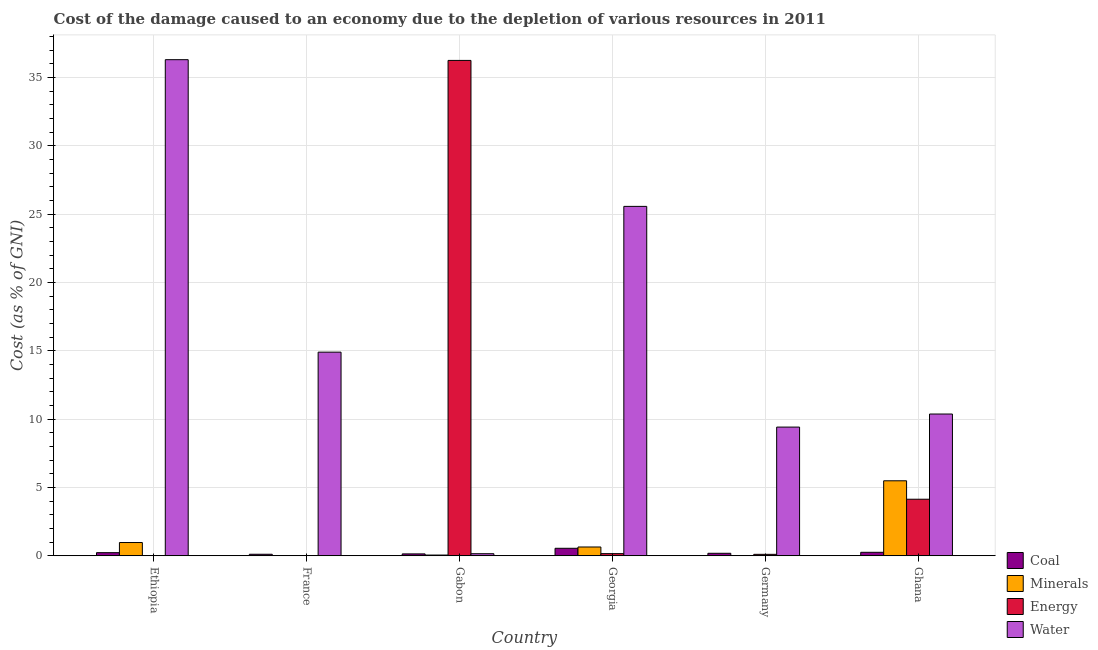How many different coloured bars are there?
Provide a succinct answer. 4. How many groups of bars are there?
Offer a terse response. 6. Are the number of bars on each tick of the X-axis equal?
Keep it short and to the point. Yes. How many bars are there on the 6th tick from the right?
Give a very brief answer. 4. What is the label of the 2nd group of bars from the left?
Make the answer very short. France. In how many cases, is the number of bars for a given country not equal to the number of legend labels?
Ensure brevity in your answer.  0. What is the cost of damage due to depletion of minerals in France?
Your answer should be compact. 0. Across all countries, what is the maximum cost of damage due to depletion of energy?
Provide a short and direct response. 36.26. Across all countries, what is the minimum cost of damage due to depletion of energy?
Your answer should be compact. 0. In which country was the cost of damage due to depletion of coal minimum?
Offer a very short reply. France. What is the total cost of damage due to depletion of coal in the graph?
Keep it short and to the point. 1.47. What is the difference between the cost of damage due to depletion of water in Ethiopia and that in France?
Your answer should be very brief. 21.41. What is the difference between the cost of damage due to depletion of water in Ethiopia and the cost of damage due to depletion of coal in France?
Your answer should be compact. 36.2. What is the average cost of damage due to depletion of energy per country?
Make the answer very short. 6.78. What is the difference between the cost of damage due to depletion of coal and cost of damage due to depletion of energy in Georgia?
Keep it short and to the point. 0.39. In how many countries, is the cost of damage due to depletion of coal greater than 35 %?
Your response must be concise. 0. What is the ratio of the cost of damage due to depletion of minerals in Gabon to that in Germany?
Your answer should be very brief. 79.27. Is the cost of damage due to depletion of water in Ethiopia less than that in Ghana?
Offer a very short reply. No. Is the difference between the cost of damage due to depletion of minerals in Ethiopia and Gabon greater than the difference between the cost of damage due to depletion of coal in Ethiopia and Gabon?
Your answer should be compact. Yes. What is the difference between the highest and the second highest cost of damage due to depletion of energy?
Ensure brevity in your answer.  32.12. What is the difference between the highest and the lowest cost of damage due to depletion of energy?
Keep it short and to the point. 36.25. In how many countries, is the cost of damage due to depletion of minerals greater than the average cost of damage due to depletion of minerals taken over all countries?
Make the answer very short. 1. What does the 1st bar from the left in Georgia represents?
Keep it short and to the point. Coal. What does the 2nd bar from the right in Germany represents?
Offer a terse response. Energy. Is it the case that in every country, the sum of the cost of damage due to depletion of coal and cost of damage due to depletion of minerals is greater than the cost of damage due to depletion of energy?
Ensure brevity in your answer.  No. Are all the bars in the graph horizontal?
Your response must be concise. No. How many countries are there in the graph?
Offer a terse response. 6. What is the difference between two consecutive major ticks on the Y-axis?
Offer a very short reply. 5. Are the values on the major ticks of Y-axis written in scientific E-notation?
Keep it short and to the point. No. What is the title of the graph?
Provide a short and direct response. Cost of the damage caused to an economy due to the depletion of various resources in 2011 . What is the label or title of the Y-axis?
Your response must be concise. Cost (as % of GNI). What is the Cost (as % of GNI) of Coal in Ethiopia?
Give a very brief answer. 0.23. What is the Cost (as % of GNI) in Minerals in Ethiopia?
Provide a short and direct response. 0.97. What is the Cost (as % of GNI) of Energy in Ethiopia?
Ensure brevity in your answer.  0. What is the Cost (as % of GNI) of Water in Ethiopia?
Provide a succinct answer. 36.31. What is the Cost (as % of GNI) of Coal in France?
Your response must be concise. 0.11. What is the Cost (as % of GNI) of Minerals in France?
Ensure brevity in your answer.  0. What is the Cost (as % of GNI) in Energy in France?
Make the answer very short. 0.02. What is the Cost (as % of GNI) of Water in France?
Make the answer very short. 14.91. What is the Cost (as % of GNI) of Coal in Gabon?
Offer a terse response. 0.14. What is the Cost (as % of GNI) in Minerals in Gabon?
Offer a terse response. 0.05. What is the Cost (as % of GNI) in Energy in Gabon?
Offer a very short reply. 36.26. What is the Cost (as % of GNI) of Water in Gabon?
Your answer should be compact. 0.15. What is the Cost (as % of GNI) of Coal in Georgia?
Ensure brevity in your answer.  0.55. What is the Cost (as % of GNI) in Minerals in Georgia?
Give a very brief answer. 0.64. What is the Cost (as % of GNI) of Energy in Georgia?
Your answer should be very brief. 0.16. What is the Cost (as % of GNI) in Water in Georgia?
Give a very brief answer. 25.57. What is the Cost (as % of GNI) of Coal in Germany?
Provide a short and direct response. 0.18. What is the Cost (as % of GNI) in Minerals in Germany?
Provide a short and direct response. 0. What is the Cost (as % of GNI) in Energy in Germany?
Offer a very short reply. 0.11. What is the Cost (as % of GNI) in Water in Germany?
Make the answer very short. 9.42. What is the Cost (as % of GNI) of Coal in Ghana?
Offer a terse response. 0.25. What is the Cost (as % of GNI) in Minerals in Ghana?
Keep it short and to the point. 5.49. What is the Cost (as % of GNI) in Energy in Ghana?
Ensure brevity in your answer.  4.14. What is the Cost (as % of GNI) of Water in Ghana?
Make the answer very short. 10.38. Across all countries, what is the maximum Cost (as % of GNI) in Coal?
Ensure brevity in your answer.  0.55. Across all countries, what is the maximum Cost (as % of GNI) of Minerals?
Make the answer very short. 5.49. Across all countries, what is the maximum Cost (as % of GNI) of Energy?
Provide a succinct answer. 36.26. Across all countries, what is the maximum Cost (as % of GNI) in Water?
Keep it short and to the point. 36.31. Across all countries, what is the minimum Cost (as % of GNI) in Coal?
Provide a succinct answer. 0.11. Across all countries, what is the minimum Cost (as % of GNI) of Minerals?
Ensure brevity in your answer.  0. Across all countries, what is the minimum Cost (as % of GNI) of Energy?
Your answer should be compact. 0. Across all countries, what is the minimum Cost (as % of GNI) in Water?
Offer a terse response. 0.15. What is the total Cost (as % of GNI) of Coal in the graph?
Provide a succinct answer. 1.47. What is the total Cost (as % of GNI) in Minerals in the graph?
Your response must be concise. 7.16. What is the total Cost (as % of GNI) of Energy in the graph?
Offer a terse response. 40.68. What is the total Cost (as % of GNI) of Water in the graph?
Make the answer very short. 96.74. What is the difference between the Cost (as % of GNI) of Coal in Ethiopia and that in France?
Offer a very short reply. 0.12. What is the difference between the Cost (as % of GNI) of Minerals in Ethiopia and that in France?
Your answer should be very brief. 0.97. What is the difference between the Cost (as % of GNI) in Energy in Ethiopia and that in France?
Your answer should be compact. -0.01. What is the difference between the Cost (as % of GNI) in Water in Ethiopia and that in France?
Your answer should be compact. 21.41. What is the difference between the Cost (as % of GNI) in Coal in Ethiopia and that in Gabon?
Make the answer very short. 0.09. What is the difference between the Cost (as % of GNI) of Minerals in Ethiopia and that in Gabon?
Offer a very short reply. 0.92. What is the difference between the Cost (as % of GNI) of Energy in Ethiopia and that in Gabon?
Offer a terse response. -36.25. What is the difference between the Cost (as % of GNI) in Water in Ethiopia and that in Gabon?
Your answer should be compact. 36.16. What is the difference between the Cost (as % of GNI) in Coal in Ethiopia and that in Georgia?
Your answer should be compact. -0.32. What is the difference between the Cost (as % of GNI) in Minerals in Ethiopia and that in Georgia?
Provide a short and direct response. 0.33. What is the difference between the Cost (as % of GNI) of Energy in Ethiopia and that in Georgia?
Keep it short and to the point. -0.16. What is the difference between the Cost (as % of GNI) in Water in Ethiopia and that in Georgia?
Your response must be concise. 10.74. What is the difference between the Cost (as % of GNI) in Coal in Ethiopia and that in Germany?
Your response must be concise. 0.05. What is the difference between the Cost (as % of GNI) in Energy in Ethiopia and that in Germany?
Give a very brief answer. -0.1. What is the difference between the Cost (as % of GNI) of Water in Ethiopia and that in Germany?
Keep it short and to the point. 26.89. What is the difference between the Cost (as % of GNI) in Coal in Ethiopia and that in Ghana?
Your answer should be very brief. -0.03. What is the difference between the Cost (as % of GNI) in Minerals in Ethiopia and that in Ghana?
Provide a succinct answer. -4.52. What is the difference between the Cost (as % of GNI) in Energy in Ethiopia and that in Ghana?
Make the answer very short. -4.14. What is the difference between the Cost (as % of GNI) in Water in Ethiopia and that in Ghana?
Keep it short and to the point. 25.93. What is the difference between the Cost (as % of GNI) in Coal in France and that in Gabon?
Provide a succinct answer. -0.03. What is the difference between the Cost (as % of GNI) in Minerals in France and that in Gabon?
Your answer should be very brief. -0.05. What is the difference between the Cost (as % of GNI) in Energy in France and that in Gabon?
Offer a terse response. -36.24. What is the difference between the Cost (as % of GNI) in Water in France and that in Gabon?
Ensure brevity in your answer.  14.75. What is the difference between the Cost (as % of GNI) of Coal in France and that in Georgia?
Provide a short and direct response. -0.44. What is the difference between the Cost (as % of GNI) in Minerals in France and that in Georgia?
Offer a terse response. -0.64. What is the difference between the Cost (as % of GNI) of Energy in France and that in Georgia?
Keep it short and to the point. -0.14. What is the difference between the Cost (as % of GNI) in Water in France and that in Georgia?
Provide a succinct answer. -10.67. What is the difference between the Cost (as % of GNI) in Coal in France and that in Germany?
Offer a terse response. -0.07. What is the difference between the Cost (as % of GNI) in Minerals in France and that in Germany?
Offer a terse response. 0. What is the difference between the Cost (as % of GNI) in Energy in France and that in Germany?
Your response must be concise. -0.09. What is the difference between the Cost (as % of GNI) in Water in France and that in Germany?
Keep it short and to the point. 5.49. What is the difference between the Cost (as % of GNI) of Coal in France and that in Ghana?
Provide a short and direct response. -0.14. What is the difference between the Cost (as % of GNI) in Minerals in France and that in Ghana?
Your answer should be compact. -5.49. What is the difference between the Cost (as % of GNI) in Energy in France and that in Ghana?
Ensure brevity in your answer.  -4.12. What is the difference between the Cost (as % of GNI) of Water in France and that in Ghana?
Your response must be concise. 4.53. What is the difference between the Cost (as % of GNI) of Coal in Gabon and that in Georgia?
Your response must be concise. -0.41. What is the difference between the Cost (as % of GNI) of Minerals in Gabon and that in Georgia?
Your answer should be very brief. -0.59. What is the difference between the Cost (as % of GNI) of Energy in Gabon and that in Georgia?
Your response must be concise. 36.1. What is the difference between the Cost (as % of GNI) of Water in Gabon and that in Georgia?
Give a very brief answer. -25.42. What is the difference between the Cost (as % of GNI) in Coal in Gabon and that in Germany?
Provide a short and direct response. -0.04. What is the difference between the Cost (as % of GNI) of Minerals in Gabon and that in Germany?
Give a very brief answer. 0.05. What is the difference between the Cost (as % of GNI) in Energy in Gabon and that in Germany?
Make the answer very short. 36.15. What is the difference between the Cost (as % of GNI) in Water in Gabon and that in Germany?
Your response must be concise. -9.27. What is the difference between the Cost (as % of GNI) in Coal in Gabon and that in Ghana?
Make the answer very short. -0.12. What is the difference between the Cost (as % of GNI) in Minerals in Gabon and that in Ghana?
Your answer should be compact. -5.44. What is the difference between the Cost (as % of GNI) of Energy in Gabon and that in Ghana?
Ensure brevity in your answer.  32.12. What is the difference between the Cost (as % of GNI) in Water in Gabon and that in Ghana?
Provide a succinct answer. -10.22. What is the difference between the Cost (as % of GNI) of Coal in Georgia and that in Germany?
Your answer should be compact. 0.36. What is the difference between the Cost (as % of GNI) of Minerals in Georgia and that in Germany?
Provide a succinct answer. 0.64. What is the difference between the Cost (as % of GNI) in Energy in Georgia and that in Germany?
Give a very brief answer. 0.05. What is the difference between the Cost (as % of GNI) of Water in Georgia and that in Germany?
Provide a succinct answer. 16.15. What is the difference between the Cost (as % of GNI) in Coal in Georgia and that in Ghana?
Make the answer very short. 0.29. What is the difference between the Cost (as % of GNI) of Minerals in Georgia and that in Ghana?
Your answer should be very brief. -4.84. What is the difference between the Cost (as % of GNI) of Energy in Georgia and that in Ghana?
Offer a terse response. -3.98. What is the difference between the Cost (as % of GNI) of Water in Georgia and that in Ghana?
Offer a terse response. 15.2. What is the difference between the Cost (as % of GNI) of Coal in Germany and that in Ghana?
Make the answer very short. -0.07. What is the difference between the Cost (as % of GNI) in Minerals in Germany and that in Ghana?
Your answer should be very brief. -5.49. What is the difference between the Cost (as % of GNI) in Energy in Germany and that in Ghana?
Make the answer very short. -4.03. What is the difference between the Cost (as % of GNI) in Water in Germany and that in Ghana?
Your answer should be very brief. -0.96. What is the difference between the Cost (as % of GNI) in Coal in Ethiopia and the Cost (as % of GNI) in Minerals in France?
Keep it short and to the point. 0.23. What is the difference between the Cost (as % of GNI) in Coal in Ethiopia and the Cost (as % of GNI) in Energy in France?
Ensure brevity in your answer.  0.21. What is the difference between the Cost (as % of GNI) in Coal in Ethiopia and the Cost (as % of GNI) in Water in France?
Provide a short and direct response. -14.68. What is the difference between the Cost (as % of GNI) in Minerals in Ethiopia and the Cost (as % of GNI) in Energy in France?
Offer a very short reply. 0.95. What is the difference between the Cost (as % of GNI) of Minerals in Ethiopia and the Cost (as % of GNI) of Water in France?
Offer a terse response. -13.93. What is the difference between the Cost (as % of GNI) of Energy in Ethiopia and the Cost (as % of GNI) of Water in France?
Offer a terse response. -14.9. What is the difference between the Cost (as % of GNI) in Coal in Ethiopia and the Cost (as % of GNI) in Minerals in Gabon?
Provide a short and direct response. 0.18. What is the difference between the Cost (as % of GNI) of Coal in Ethiopia and the Cost (as % of GNI) of Energy in Gabon?
Give a very brief answer. -36.03. What is the difference between the Cost (as % of GNI) of Coal in Ethiopia and the Cost (as % of GNI) of Water in Gabon?
Ensure brevity in your answer.  0.08. What is the difference between the Cost (as % of GNI) in Minerals in Ethiopia and the Cost (as % of GNI) in Energy in Gabon?
Your response must be concise. -35.29. What is the difference between the Cost (as % of GNI) of Minerals in Ethiopia and the Cost (as % of GNI) of Water in Gabon?
Your response must be concise. 0.82. What is the difference between the Cost (as % of GNI) in Energy in Ethiopia and the Cost (as % of GNI) in Water in Gabon?
Your response must be concise. -0.15. What is the difference between the Cost (as % of GNI) in Coal in Ethiopia and the Cost (as % of GNI) in Minerals in Georgia?
Make the answer very short. -0.42. What is the difference between the Cost (as % of GNI) in Coal in Ethiopia and the Cost (as % of GNI) in Energy in Georgia?
Your response must be concise. 0.07. What is the difference between the Cost (as % of GNI) in Coal in Ethiopia and the Cost (as % of GNI) in Water in Georgia?
Keep it short and to the point. -25.34. What is the difference between the Cost (as % of GNI) of Minerals in Ethiopia and the Cost (as % of GNI) of Energy in Georgia?
Your answer should be compact. 0.81. What is the difference between the Cost (as % of GNI) in Minerals in Ethiopia and the Cost (as % of GNI) in Water in Georgia?
Your response must be concise. -24.6. What is the difference between the Cost (as % of GNI) in Energy in Ethiopia and the Cost (as % of GNI) in Water in Georgia?
Offer a very short reply. -25.57. What is the difference between the Cost (as % of GNI) of Coal in Ethiopia and the Cost (as % of GNI) of Minerals in Germany?
Ensure brevity in your answer.  0.23. What is the difference between the Cost (as % of GNI) of Coal in Ethiopia and the Cost (as % of GNI) of Energy in Germany?
Offer a terse response. 0.12. What is the difference between the Cost (as % of GNI) in Coal in Ethiopia and the Cost (as % of GNI) in Water in Germany?
Provide a short and direct response. -9.19. What is the difference between the Cost (as % of GNI) of Minerals in Ethiopia and the Cost (as % of GNI) of Energy in Germany?
Provide a short and direct response. 0.86. What is the difference between the Cost (as % of GNI) of Minerals in Ethiopia and the Cost (as % of GNI) of Water in Germany?
Your answer should be compact. -8.45. What is the difference between the Cost (as % of GNI) in Energy in Ethiopia and the Cost (as % of GNI) in Water in Germany?
Provide a short and direct response. -9.42. What is the difference between the Cost (as % of GNI) of Coal in Ethiopia and the Cost (as % of GNI) of Minerals in Ghana?
Give a very brief answer. -5.26. What is the difference between the Cost (as % of GNI) of Coal in Ethiopia and the Cost (as % of GNI) of Energy in Ghana?
Your answer should be very brief. -3.91. What is the difference between the Cost (as % of GNI) in Coal in Ethiopia and the Cost (as % of GNI) in Water in Ghana?
Your answer should be compact. -10.15. What is the difference between the Cost (as % of GNI) of Minerals in Ethiopia and the Cost (as % of GNI) of Energy in Ghana?
Offer a very short reply. -3.17. What is the difference between the Cost (as % of GNI) of Minerals in Ethiopia and the Cost (as % of GNI) of Water in Ghana?
Your answer should be compact. -9.4. What is the difference between the Cost (as % of GNI) in Energy in Ethiopia and the Cost (as % of GNI) in Water in Ghana?
Keep it short and to the point. -10.37. What is the difference between the Cost (as % of GNI) in Coal in France and the Cost (as % of GNI) in Minerals in Gabon?
Provide a short and direct response. 0.06. What is the difference between the Cost (as % of GNI) in Coal in France and the Cost (as % of GNI) in Energy in Gabon?
Provide a short and direct response. -36.14. What is the difference between the Cost (as % of GNI) in Coal in France and the Cost (as % of GNI) in Water in Gabon?
Offer a very short reply. -0.04. What is the difference between the Cost (as % of GNI) in Minerals in France and the Cost (as % of GNI) in Energy in Gabon?
Keep it short and to the point. -36.26. What is the difference between the Cost (as % of GNI) in Minerals in France and the Cost (as % of GNI) in Water in Gabon?
Your response must be concise. -0.15. What is the difference between the Cost (as % of GNI) of Energy in France and the Cost (as % of GNI) of Water in Gabon?
Provide a succinct answer. -0.14. What is the difference between the Cost (as % of GNI) of Coal in France and the Cost (as % of GNI) of Minerals in Georgia?
Your response must be concise. -0.53. What is the difference between the Cost (as % of GNI) of Coal in France and the Cost (as % of GNI) of Energy in Georgia?
Your answer should be compact. -0.05. What is the difference between the Cost (as % of GNI) of Coal in France and the Cost (as % of GNI) of Water in Georgia?
Give a very brief answer. -25.46. What is the difference between the Cost (as % of GNI) of Minerals in France and the Cost (as % of GNI) of Energy in Georgia?
Make the answer very short. -0.16. What is the difference between the Cost (as % of GNI) of Minerals in France and the Cost (as % of GNI) of Water in Georgia?
Keep it short and to the point. -25.57. What is the difference between the Cost (as % of GNI) of Energy in France and the Cost (as % of GNI) of Water in Georgia?
Provide a succinct answer. -25.56. What is the difference between the Cost (as % of GNI) in Coal in France and the Cost (as % of GNI) in Minerals in Germany?
Your response must be concise. 0.11. What is the difference between the Cost (as % of GNI) of Coal in France and the Cost (as % of GNI) of Energy in Germany?
Your answer should be compact. 0.01. What is the difference between the Cost (as % of GNI) in Coal in France and the Cost (as % of GNI) in Water in Germany?
Make the answer very short. -9.31. What is the difference between the Cost (as % of GNI) in Minerals in France and the Cost (as % of GNI) in Energy in Germany?
Offer a terse response. -0.11. What is the difference between the Cost (as % of GNI) of Minerals in France and the Cost (as % of GNI) of Water in Germany?
Offer a very short reply. -9.42. What is the difference between the Cost (as % of GNI) of Energy in France and the Cost (as % of GNI) of Water in Germany?
Your answer should be very brief. -9.4. What is the difference between the Cost (as % of GNI) of Coal in France and the Cost (as % of GNI) of Minerals in Ghana?
Your answer should be very brief. -5.38. What is the difference between the Cost (as % of GNI) of Coal in France and the Cost (as % of GNI) of Energy in Ghana?
Provide a short and direct response. -4.03. What is the difference between the Cost (as % of GNI) of Coal in France and the Cost (as % of GNI) of Water in Ghana?
Your response must be concise. -10.26. What is the difference between the Cost (as % of GNI) in Minerals in France and the Cost (as % of GNI) in Energy in Ghana?
Ensure brevity in your answer.  -4.14. What is the difference between the Cost (as % of GNI) of Minerals in France and the Cost (as % of GNI) of Water in Ghana?
Your response must be concise. -10.37. What is the difference between the Cost (as % of GNI) of Energy in France and the Cost (as % of GNI) of Water in Ghana?
Make the answer very short. -10.36. What is the difference between the Cost (as % of GNI) of Coal in Gabon and the Cost (as % of GNI) of Minerals in Georgia?
Offer a terse response. -0.51. What is the difference between the Cost (as % of GNI) in Coal in Gabon and the Cost (as % of GNI) in Energy in Georgia?
Offer a terse response. -0.02. What is the difference between the Cost (as % of GNI) of Coal in Gabon and the Cost (as % of GNI) of Water in Georgia?
Offer a very short reply. -25.43. What is the difference between the Cost (as % of GNI) in Minerals in Gabon and the Cost (as % of GNI) in Energy in Georgia?
Provide a short and direct response. -0.1. What is the difference between the Cost (as % of GNI) in Minerals in Gabon and the Cost (as % of GNI) in Water in Georgia?
Keep it short and to the point. -25.52. What is the difference between the Cost (as % of GNI) in Energy in Gabon and the Cost (as % of GNI) in Water in Georgia?
Offer a very short reply. 10.68. What is the difference between the Cost (as % of GNI) in Coal in Gabon and the Cost (as % of GNI) in Minerals in Germany?
Provide a succinct answer. 0.14. What is the difference between the Cost (as % of GNI) of Coal in Gabon and the Cost (as % of GNI) of Energy in Germany?
Your answer should be compact. 0.03. What is the difference between the Cost (as % of GNI) in Coal in Gabon and the Cost (as % of GNI) in Water in Germany?
Your answer should be compact. -9.28. What is the difference between the Cost (as % of GNI) in Minerals in Gabon and the Cost (as % of GNI) in Energy in Germany?
Give a very brief answer. -0.05. What is the difference between the Cost (as % of GNI) in Minerals in Gabon and the Cost (as % of GNI) in Water in Germany?
Offer a terse response. -9.37. What is the difference between the Cost (as % of GNI) of Energy in Gabon and the Cost (as % of GNI) of Water in Germany?
Ensure brevity in your answer.  26.84. What is the difference between the Cost (as % of GNI) of Coal in Gabon and the Cost (as % of GNI) of Minerals in Ghana?
Your response must be concise. -5.35. What is the difference between the Cost (as % of GNI) in Coal in Gabon and the Cost (as % of GNI) in Energy in Ghana?
Make the answer very short. -4. What is the difference between the Cost (as % of GNI) of Coal in Gabon and the Cost (as % of GNI) of Water in Ghana?
Provide a short and direct response. -10.24. What is the difference between the Cost (as % of GNI) in Minerals in Gabon and the Cost (as % of GNI) in Energy in Ghana?
Your answer should be very brief. -4.09. What is the difference between the Cost (as % of GNI) of Minerals in Gabon and the Cost (as % of GNI) of Water in Ghana?
Give a very brief answer. -10.32. What is the difference between the Cost (as % of GNI) in Energy in Gabon and the Cost (as % of GNI) in Water in Ghana?
Your answer should be very brief. 25.88. What is the difference between the Cost (as % of GNI) of Coal in Georgia and the Cost (as % of GNI) of Minerals in Germany?
Ensure brevity in your answer.  0.55. What is the difference between the Cost (as % of GNI) of Coal in Georgia and the Cost (as % of GNI) of Energy in Germany?
Give a very brief answer. 0.44. What is the difference between the Cost (as % of GNI) of Coal in Georgia and the Cost (as % of GNI) of Water in Germany?
Your answer should be compact. -8.87. What is the difference between the Cost (as % of GNI) in Minerals in Georgia and the Cost (as % of GNI) in Energy in Germany?
Your answer should be very brief. 0.54. What is the difference between the Cost (as % of GNI) in Minerals in Georgia and the Cost (as % of GNI) in Water in Germany?
Your response must be concise. -8.78. What is the difference between the Cost (as % of GNI) in Energy in Georgia and the Cost (as % of GNI) in Water in Germany?
Ensure brevity in your answer.  -9.26. What is the difference between the Cost (as % of GNI) of Coal in Georgia and the Cost (as % of GNI) of Minerals in Ghana?
Your answer should be compact. -4.94. What is the difference between the Cost (as % of GNI) in Coal in Georgia and the Cost (as % of GNI) in Energy in Ghana?
Keep it short and to the point. -3.59. What is the difference between the Cost (as % of GNI) of Coal in Georgia and the Cost (as % of GNI) of Water in Ghana?
Your response must be concise. -9.83. What is the difference between the Cost (as % of GNI) of Minerals in Georgia and the Cost (as % of GNI) of Energy in Ghana?
Provide a short and direct response. -3.5. What is the difference between the Cost (as % of GNI) in Minerals in Georgia and the Cost (as % of GNI) in Water in Ghana?
Offer a very short reply. -9.73. What is the difference between the Cost (as % of GNI) in Energy in Georgia and the Cost (as % of GNI) in Water in Ghana?
Your answer should be very brief. -10.22. What is the difference between the Cost (as % of GNI) in Coal in Germany and the Cost (as % of GNI) in Minerals in Ghana?
Your answer should be compact. -5.31. What is the difference between the Cost (as % of GNI) in Coal in Germany and the Cost (as % of GNI) in Energy in Ghana?
Provide a succinct answer. -3.96. What is the difference between the Cost (as % of GNI) in Coal in Germany and the Cost (as % of GNI) in Water in Ghana?
Ensure brevity in your answer.  -10.19. What is the difference between the Cost (as % of GNI) of Minerals in Germany and the Cost (as % of GNI) of Energy in Ghana?
Make the answer very short. -4.14. What is the difference between the Cost (as % of GNI) of Minerals in Germany and the Cost (as % of GNI) of Water in Ghana?
Your response must be concise. -10.38. What is the difference between the Cost (as % of GNI) of Energy in Germany and the Cost (as % of GNI) of Water in Ghana?
Make the answer very short. -10.27. What is the average Cost (as % of GNI) of Coal per country?
Keep it short and to the point. 0.24. What is the average Cost (as % of GNI) in Minerals per country?
Make the answer very short. 1.19. What is the average Cost (as % of GNI) in Energy per country?
Your answer should be compact. 6.78. What is the average Cost (as % of GNI) of Water per country?
Your answer should be compact. 16.12. What is the difference between the Cost (as % of GNI) of Coal and Cost (as % of GNI) of Minerals in Ethiopia?
Your answer should be compact. -0.74. What is the difference between the Cost (as % of GNI) in Coal and Cost (as % of GNI) in Energy in Ethiopia?
Ensure brevity in your answer.  0.23. What is the difference between the Cost (as % of GNI) in Coal and Cost (as % of GNI) in Water in Ethiopia?
Keep it short and to the point. -36.08. What is the difference between the Cost (as % of GNI) in Minerals and Cost (as % of GNI) in Energy in Ethiopia?
Ensure brevity in your answer.  0.97. What is the difference between the Cost (as % of GNI) of Minerals and Cost (as % of GNI) of Water in Ethiopia?
Give a very brief answer. -35.34. What is the difference between the Cost (as % of GNI) in Energy and Cost (as % of GNI) in Water in Ethiopia?
Make the answer very short. -36.31. What is the difference between the Cost (as % of GNI) of Coal and Cost (as % of GNI) of Minerals in France?
Your answer should be compact. 0.11. What is the difference between the Cost (as % of GNI) of Coal and Cost (as % of GNI) of Energy in France?
Make the answer very short. 0.1. What is the difference between the Cost (as % of GNI) in Coal and Cost (as % of GNI) in Water in France?
Give a very brief answer. -14.79. What is the difference between the Cost (as % of GNI) of Minerals and Cost (as % of GNI) of Energy in France?
Ensure brevity in your answer.  -0.02. What is the difference between the Cost (as % of GNI) in Minerals and Cost (as % of GNI) in Water in France?
Provide a succinct answer. -14.9. What is the difference between the Cost (as % of GNI) of Energy and Cost (as % of GNI) of Water in France?
Give a very brief answer. -14.89. What is the difference between the Cost (as % of GNI) of Coal and Cost (as % of GNI) of Minerals in Gabon?
Make the answer very short. 0.08. What is the difference between the Cost (as % of GNI) of Coal and Cost (as % of GNI) of Energy in Gabon?
Make the answer very short. -36.12. What is the difference between the Cost (as % of GNI) in Coal and Cost (as % of GNI) in Water in Gabon?
Ensure brevity in your answer.  -0.01. What is the difference between the Cost (as % of GNI) in Minerals and Cost (as % of GNI) in Energy in Gabon?
Your answer should be compact. -36.2. What is the difference between the Cost (as % of GNI) in Minerals and Cost (as % of GNI) in Water in Gabon?
Provide a short and direct response. -0.1. What is the difference between the Cost (as % of GNI) of Energy and Cost (as % of GNI) of Water in Gabon?
Your response must be concise. 36.1. What is the difference between the Cost (as % of GNI) in Coal and Cost (as % of GNI) in Minerals in Georgia?
Provide a short and direct response. -0.1. What is the difference between the Cost (as % of GNI) of Coal and Cost (as % of GNI) of Energy in Georgia?
Ensure brevity in your answer.  0.39. What is the difference between the Cost (as % of GNI) in Coal and Cost (as % of GNI) in Water in Georgia?
Offer a terse response. -25.02. What is the difference between the Cost (as % of GNI) in Minerals and Cost (as % of GNI) in Energy in Georgia?
Your response must be concise. 0.49. What is the difference between the Cost (as % of GNI) in Minerals and Cost (as % of GNI) in Water in Georgia?
Offer a terse response. -24.93. What is the difference between the Cost (as % of GNI) of Energy and Cost (as % of GNI) of Water in Georgia?
Your answer should be very brief. -25.42. What is the difference between the Cost (as % of GNI) of Coal and Cost (as % of GNI) of Minerals in Germany?
Give a very brief answer. 0.18. What is the difference between the Cost (as % of GNI) in Coal and Cost (as % of GNI) in Energy in Germany?
Provide a succinct answer. 0.08. What is the difference between the Cost (as % of GNI) of Coal and Cost (as % of GNI) of Water in Germany?
Offer a very short reply. -9.24. What is the difference between the Cost (as % of GNI) in Minerals and Cost (as % of GNI) in Energy in Germany?
Provide a succinct answer. -0.11. What is the difference between the Cost (as % of GNI) of Minerals and Cost (as % of GNI) of Water in Germany?
Make the answer very short. -9.42. What is the difference between the Cost (as % of GNI) in Energy and Cost (as % of GNI) in Water in Germany?
Keep it short and to the point. -9.31. What is the difference between the Cost (as % of GNI) in Coal and Cost (as % of GNI) in Minerals in Ghana?
Give a very brief answer. -5.23. What is the difference between the Cost (as % of GNI) in Coal and Cost (as % of GNI) in Energy in Ghana?
Your answer should be very brief. -3.88. What is the difference between the Cost (as % of GNI) of Coal and Cost (as % of GNI) of Water in Ghana?
Offer a terse response. -10.12. What is the difference between the Cost (as % of GNI) of Minerals and Cost (as % of GNI) of Energy in Ghana?
Ensure brevity in your answer.  1.35. What is the difference between the Cost (as % of GNI) in Minerals and Cost (as % of GNI) in Water in Ghana?
Keep it short and to the point. -4.89. What is the difference between the Cost (as % of GNI) in Energy and Cost (as % of GNI) in Water in Ghana?
Offer a terse response. -6.24. What is the ratio of the Cost (as % of GNI) in Coal in Ethiopia to that in France?
Ensure brevity in your answer.  2.04. What is the ratio of the Cost (as % of GNI) in Minerals in Ethiopia to that in France?
Your response must be concise. 634.23. What is the ratio of the Cost (as % of GNI) in Energy in Ethiopia to that in France?
Provide a succinct answer. 0.17. What is the ratio of the Cost (as % of GNI) in Water in Ethiopia to that in France?
Keep it short and to the point. 2.44. What is the ratio of the Cost (as % of GNI) in Coal in Ethiopia to that in Gabon?
Give a very brief answer. 1.65. What is the ratio of the Cost (as % of GNI) of Minerals in Ethiopia to that in Gabon?
Give a very brief answer. 17.98. What is the ratio of the Cost (as % of GNI) of Energy in Ethiopia to that in Gabon?
Offer a very short reply. 0. What is the ratio of the Cost (as % of GNI) in Water in Ethiopia to that in Gabon?
Your answer should be compact. 237.61. What is the ratio of the Cost (as % of GNI) in Coal in Ethiopia to that in Georgia?
Your answer should be compact. 0.42. What is the ratio of the Cost (as % of GNI) of Minerals in Ethiopia to that in Georgia?
Provide a succinct answer. 1.51. What is the ratio of the Cost (as % of GNI) of Energy in Ethiopia to that in Georgia?
Provide a short and direct response. 0.02. What is the ratio of the Cost (as % of GNI) of Water in Ethiopia to that in Georgia?
Keep it short and to the point. 1.42. What is the ratio of the Cost (as % of GNI) of Coal in Ethiopia to that in Germany?
Offer a very short reply. 1.25. What is the ratio of the Cost (as % of GNI) of Minerals in Ethiopia to that in Germany?
Offer a terse response. 1425.1. What is the ratio of the Cost (as % of GNI) in Energy in Ethiopia to that in Germany?
Make the answer very short. 0.03. What is the ratio of the Cost (as % of GNI) in Water in Ethiopia to that in Germany?
Offer a very short reply. 3.85. What is the ratio of the Cost (as % of GNI) of Coal in Ethiopia to that in Ghana?
Offer a very short reply. 0.9. What is the ratio of the Cost (as % of GNI) in Minerals in Ethiopia to that in Ghana?
Give a very brief answer. 0.18. What is the ratio of the Cost (as % of GNI) in Energy in Ethiopia to that in Ghana?
Your response must be concise. 0. What is the ratio of the Cost (as % of GNI) of Water in Ethiopia to that in Ghana?
Give a very brief answer. 3.5. What is the ratio of the Cost (as % of GNI) of Coal in France to that in Gabon?
Offer a terse response. 0.81. What is the ratio of the Cost (as % of GNI) of Minerals in France to that in Gabon?
Provide a short and direct response. 0.03. What is the ratio of the Cost (as % of GNI) of Water in France to that in Gabon?
Your answer should be very brief. 97.54. What is the ratio of the Cost (as % of GNI) in Coal in France to that in Georgia?
Your response must be concise. 0.2. What is the ratio of the Cost (as % of GNI) in Minerals in France to that in Georgia?
Give a very brief answer. 0. What is the ratio of the Cost (as % of GNI) in Energy in France to that in Georgia?
Ensure brevity in your answer.  0.11. What is the ratio of the Cost (as % of GNI) of Water in France to that in Georgia?
Provide a short and direct response. 0.58. What is the ratio of the Cost (as % of GNI) in Coal in France to that in Germany?
Your answer should be very brief. 0.61. What is the ratio of the Cost (as % of GNI) in Minerals in France to that in Germany?
Make the answer very short. 2.25. What is the ratio of the Cost (as % of GNI) of Energy in France to that in Germany?
Keep it short and to the point. 0.16. What is the ratio of the Cost (as % of GNI) in Water in France to that in Germany?
Your response must be concise. 1.58. What is the ratio of the Cost (as % of GNI) of Coal in France to that in Ghana?
Give a very brief answer. 0.44. What is the ratio of the Cost (as % of GNI) of Energy in France to that in Ghana?
Offer a very short reply. 0. What is the ratio of the Cost (as % of GNI) in Water in France to that in Ghana?
Your answer should be very brief. 1.44. What is the ratio of the Cost (as % of GNI) in Coal in Gabon to that in Georgia?
Keep it short and to the point. 0.25. What is the ratio of the Cost (as % of GNI) in Minerals in Gabon to that in Georgia?
Make the answer very short. 0.08. What is the ratio of the Cost (as % of GNI) in Energy in Gabon to that in Georgia?
Provide a succinct answer. 229.57. What is the ratio of the Cost (as % of GNI) in Water in Gabon to that in Georgia?
Your response must be concise. 0.01. What is the ratio of the Cost (as % of GNI) of Coal in Gabon to that in Germany?
Your answer should be very brief. 0.76. What is the ratio of the Cost (as % of GNI) of Minerals in Gabon to that in Germany?
Keep it short and to the point. 79.27. What is the ratio of the Cost (as % of GNI) of Energy in Gabon to that in Germany?
Provide a succinct answer. 339.12. What is the ratio of the Cost (as % of GNI) of Water in Gabon to that in Germany?
Offer a terse response. 0.02. What is the ratio of the Cost (as % of GNI) of Coal in Gabon to that in Ghana?
Provide a succinct answer. 0.55. What is the ratio of the Cost (as % of GNI) of Minerals in Gabon to that in Ghana?
Your answer should be compact. 0.01. What is the ratio of the Cost (as % of GNI) of Energy in Gabon to that in Ghana?
Provide a short and direct response. 8.76. What is the ratio of the Cost (as % of GNI) in Water in Gabon to that in Ghana?
Ensure brevity in your answer.  0.01. What is the ratio of the Cost (as % of GNI) in Coal in Georgia to that in Germany?
Provide a short and direct response. 2.99. What is the ratio of the Cost (as % of GNI) of Minerals in Georgia to that in Germany?
Make the answer very short. 945.31. What is the ratio of the Cost (as % of GNI) in Energy in Georgia to that in Germany?
Offer a terse response. 1.48. What is the ratio of the Cost (as % of GNI) in Water in Georgia to that in Germany?
Provide a short and direct response. 2.71. What is the ratio of the Cost (as % of GNI) in Coal in Georgia to that in Ghana?
Your answer should be very brief. 2.15. What is the ratio of the Cost (as % of GNI) in Minerals in Georgia to that in Ghana?
Your answer should be compact. 0.12. What is the ratio of the Cost (as % of GNI) in Energy in Georgia to that in Ghana?
Your response must be concise. 0.04. What is the ratio of the Cost (as % of GNI) in Water in Georgia to that in Ghana?
Offer a very short reply. 2.46. What is the ratio of the Cost (as % of GNI) of Coal in Germany to that in Ghana?
Ensure brevity in your answer.  0.72. What is the ratio of the Cost (as % of GNI) in Energy in Germany to that in Ghana?
Offer a terse response. 0.03. What is the ratio of the Cost (as % of GNI) of Water in Germany to that in Ghana?
Your answer should be very brief. 0.91. What is the difference between the highest and the second highest Cost (as % of GNI) in Coal?
Your answer should be compact. 0.29. What is the difference between the highest and the second highest Cost (as % of GNI) in Minerals?
Your answer should be very brief. 4.52. What is the difference between the highest and the second highest Cost (as % of GNI) in Energy?
Make the answer very short. 32.12. What is the difference between the highest and the second highest Cost (as % of GNI) in Water?
Give a very brief answer. 10.74. What is the difference between the highest and the lowest Cost (as % of GNI) in Coal?
Keep it short and to the point. 0.44. What is the difference between the highest and the lowest Cost (as % of GNI) in Minerals?
Provide a succinct answer. 5.49. What is the difference between the highest and the lowest Cost (as % of GNI) of Energy?
Keep it short and to the point. 36.25. What is the difference between the highest and the lowest Cost (as % of GNI) of Water?
Provide a short and direct response. 36.16. 